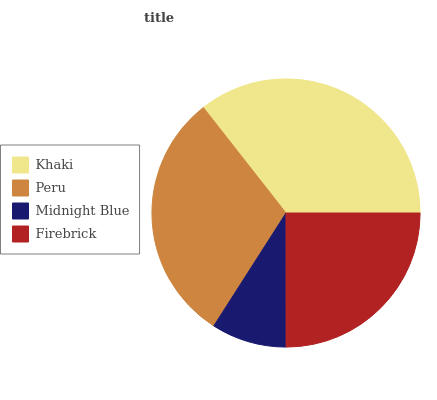Is Midnight Blue the minimum?
Answer yes or no. Yes. Is Khaki the maximum?
Answer yes or no. Yes. Is Peru the minimum?
Answer yes or no. No. Is Peru the maximum?
Answer yes or no. No. Is Khaki greater than Peru?
Answer yes or no. Yes. Is Peru less than Khaki?
Answer yes or no. Yes. Is Peru greater than Khaki?
Answer yes or no. No. Is Khaki less than Peru?
Answer yes or no. No. Is Peru the high median?
Answer yes or no. Yes. Is Firebrick the low median?
Answer yes or no. Yes. Is Firebrick the high median?
Answer yes or no. No. Is Peru the low median?
Answer yes or no. No. 